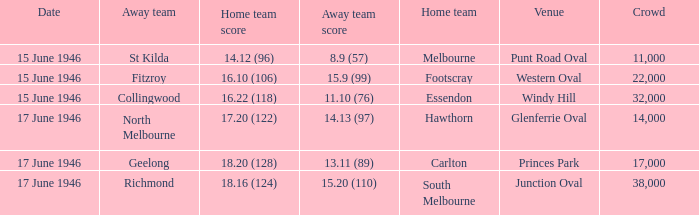On what date did a home team score 16.10 (106)? 15 June 1946. Give me the full table as a dictionary. {'header': ['Date', 'Away team', 'Home team score', 'Away team score', 'Home team', 'Venue', 'Crowd'], 'rows': [['15 June 1946', 'St Kilda', '14.12 (96)', '8.9 (57)', 'Melbourne', 'Punt Road Oval', '11,000'], ['15 June 1946', 'Fitzroy', '16.10 (106)', '15.9 (99)', 'Footscray', 'Western Oval', '22,000'], ['15 June 1946', 'Collingwood', '16.22 (118)', '11.10 (76)', 'Essendon', 'Windy Hill', '32,000'], ['17 June 1946', 'North Melbourne', '17.20 (122)', '14.13 (97)', 'Hawthorn', 'Glenferrie Oval', '14,000'], ['17 June 1946', 'Geelong', '18.20 (128)', '13.11 (89)', 'Carlton', 'Princes Park', '17,000'], ['17 June 1946', 'Richmond', '18.16 (124)', '15.20 (110)', 'South Melbourne', 'Junction Oval', '38,000']]} 